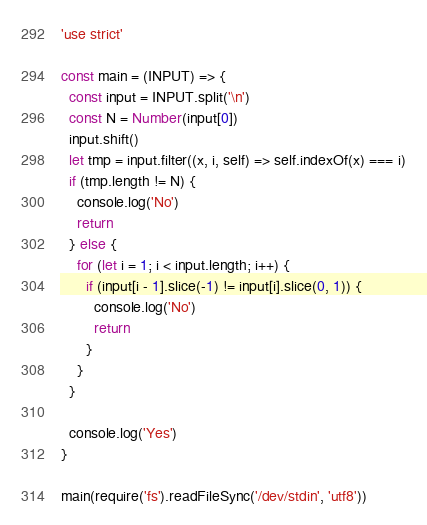<code> <loc_0><loc_0><loc_500><loc_500><_JavaScript_>'use strict'

const main = (INPUT) => {
  const input = INPUT.split('\n')
  const N = Number(input[0])
  input.shift()
  let tmp = input.filter((x, i, self) => self.indexOf(x) === i)
  if (tmp.length != N) {
    console.log('No')
    return
  } else {
    for (let i = 1; i < input.length; i++) {
      if (input[i - 1].slice(-1) != input[i].slice(0, 1)) {
        console.log('No')
        return
      }
    }
  }

  console.log('Yes')
}

main(require('fs').readFileSync('/dev/stdin', 'utf8'))
</code> 